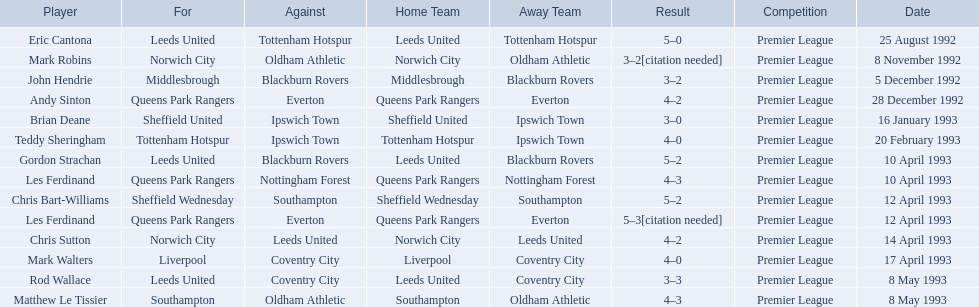Who are all the players? Eric Cantona, Mark Robins, John Hendrie, Andy Sinton, Brian Deane, Teddy Sheringham, Gordon Strachan, Les Ferdinand, Chris Bart-Williams, Les Ferdinand, Chris Sutton, Mark Walters, Rod Wallace, Matthew Le Tissier. I'm looking to parse the entire table for insights. Could you assist me with that? {'header': ['Player', 'For', 'Against', 'Home Team', 'Away Team', 'Result', 'Competition', 'Date'], 'rows': [['Eric Cantona', 'Leeds United', 'Tottenham Hotspur', 'Leeds United', 'Tottenham Hotspur', '5–0', 'Premier League', '25 August 1992'], ['Mark Robins', 'Norwich City', 'Oldham Athletic', 'Norwich City', 'Oldham Athletic', '3–2[citation needed]', 'Premier League', '8 November 1992'], ['John Hendrie', 'Middlesbrough', 'Blackburn Rovers', 'Middlesbrough', 'Blackburn Rovers', '3–2', 'Premier League', '5 December 1992'], ['Andy Sinton', 'Queens Park Rangers', 'Everton', 'Queens Park Rangers', 'Everton', '4–2', 'Premier League', '28 December 1992'], ['Brian Deane', 'Sheffield United', 'Ipswich Town', 'Sheffield United', 'Ipswich Town', '3–0', 'Premier League', '16 January 1993'], ['Teddy Sheringham', 'Tottenham Hotspur', 'Ipswich Town', 'Tottenham Hotspur', 'Ipswich Town', '4–0', 'Premier League', '20 February 1993'], ['Gordon Strachan', 'Leeds United', 'Blackburn Rovers', 'Leeds United', 'Blackburn Rovers', '5–2', 'Premier League', '10 April 1993'], ['Les Ferdinand', 'Queens Park Rangers', 'Nottingham Forest', 'Queens Park Rangers', 'Nottingham Forest', '4–3', 'Premier League', '10 April 1993'], ['Chris Bart-Williams', 'Sheffield Wednesday', 'Southampton', 'Sheffield Wednesday', 'Southampton', '5–2', 'Premier League', '12 April 1993'], ['Les Ferdinand', 'Queens Park Rangers', 'Everton', 'Queens Park Rangers', 'Everton', '5–3[citation needed]', 'Premier League', '12 April 1993'], ['Chris Sutton', 'Norwich City', 'Leeds United', 'Norwich City', 'Leeds United', '4–2', 'Premier League', '14 April 1993'], ['Mark Walters', 'Liverpool', 'Coventry City', 'Liverpool', 'Coventry City', '4–0', 'Premier League', '17 April 1993'], ['Rod Wallace', 'Leeds United', 'Coventry City', 'Leeds United', 'Coventry City', '3–3', 'Premier League', '8 May 1993'], ['Matthew Le Tissier', 'Southampton', 'Oldham Athletic', 'Southampton', 'Oldham Athletic', '4–3', 'Premier League', '8 May 1993']]} What were their results? 5–0, 3–2[citation needed], 3–2, 4–2, 3–0, 4–0, 5–2, 4–3, 5–2, 5–3[citation needed], 4–2, 4–0, 3–3, 4–3. Which player tied with mark robins? John Hendrie. 